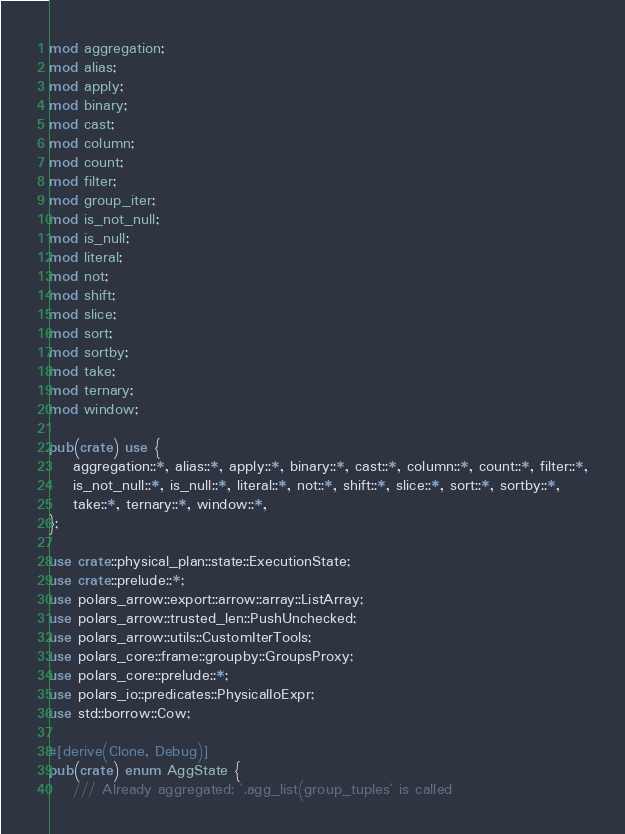Convert code to text. <code><loc_0><loc_0><loc_500><loc_500><_Rust_>mod aggregation;
mod alias;
mod apply;
mod binary;
mod cast;
mod column;
mod count;
mod filter;
mod group_iter;
mod is_not_null;
mod is_null;
mod literal;
mod not;
mod shift;
mod slice;
mod sort;
mod sortby;
mod take;
mod ternary;
mod window;

pub(crate) use {
    aggregation::*, alias::*, apply::*, binary::*, cast::*, column::*, count::*, filter::*,
    is_not_null::*, is_null::*, literal::*, not::*, shift::*, slice::*, sort::*, sortby::*,
    take::*, ternary::*, window::*,
};

use crate::physical_plan::state::ExecutionState;
use crate::prelude::*;
use polars_arrow::export::arrow::array::ListArray;
use polars_arrow::trusted_len::PushUnchecked;
use polars_arrow::utils::CustomIterTools;
use polars_core::frame::groupby::GroupsProxy;
use polars_core::prelude::*;
use polars_io::predicates::PhysicalIoExpr;
use std::borrow::Cow;

#[derive(Clone, Debug)]
pub(crate) enum AggState {
    /// Already aggregated: `.agg_list(group_tuples` is called</code> 